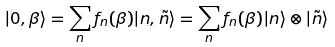<formula> <loc_0><loc_0><loc_500><loc_500>| 0 , \beta \rangle = \sum _ { n } f _ { n } ( \beta ) | n , \tilde { n } \rangle = \sum _ { n } f _ { n } ( \beta ) | n \rangle \otimes | \tilde { n } \rangle</formula> 